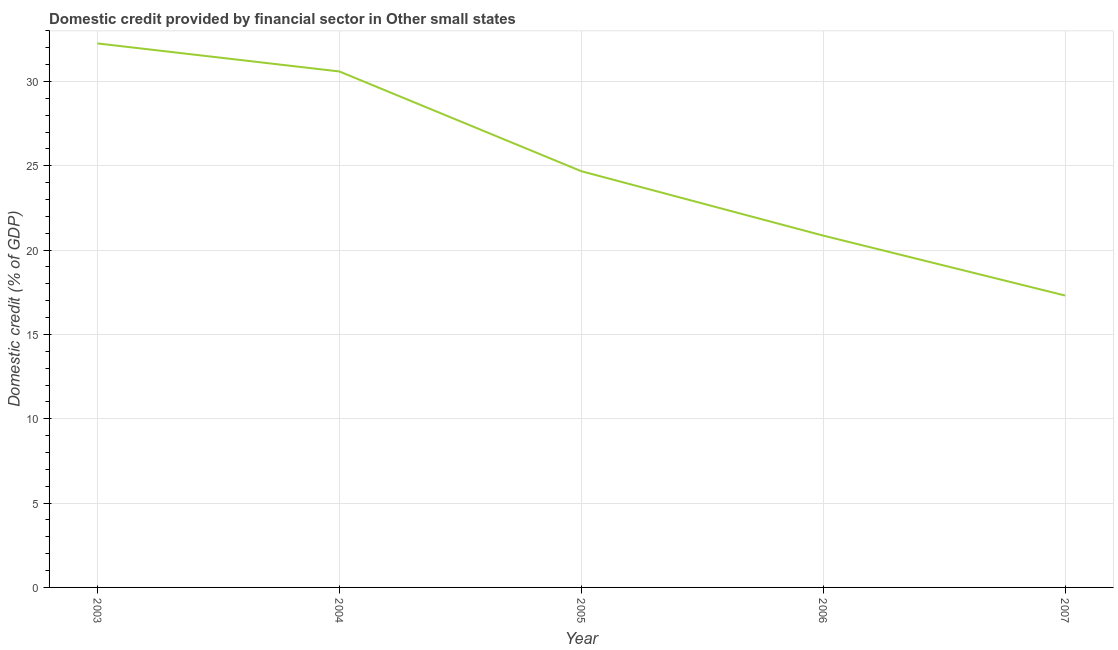What is the domestic credit provided by financial sector in 2003?
Make the answer very short. 32.26. Across all years, what is the maximum domestic credit provided by financial sector?
Provide a short and direct response. 32.26. Across all years, what is the minimum domestic credit provided by financial sector?
Ensure brevity in your answer.  17.31. In which year was the domestic credit provided by financial sector minimum?
Your answer should be very brief. 2007. What is the sum of the domestic credit provided by financial sector?
Your answer should be very brief. 125.7. What is the difference between the domestic credit provided by financial sector in 2005 and 2006?
Keep it short and to the point. 3.82. What is the average domestic credit provided by financial sector per year?
Make the answer very short. 25.14. What is the median domestic credit provided by financial sector?
Keep it short and to the point. 24.68. Do a majority of the years between 2006 and 2003 (inclusive) have domestic credit provided by financial sector greater than 27 %?
Ensure brevity in your answer.  Yes. What is the ratio of the domestic credit provided by financial sector in 2006 to that in 2007?
Your answer should be very brief. 1.21. Is the domestic credit provided by financial sector in 2003 less than that in 2007?
Keep it short and to the point. No. Is the difference between the domestic credit provided by financial sector in 2006 and 2007 greater than the difference between any two years?
Keep it short and to the point. No. What is the difference between the highest and the second highest domestic credit provided by financial sector?
Provide a short and direct response. 1.66. What is the difference between the highest and the lowest domestic credit provided by financial sector?
Give a very brief answer. 14.95. In how many years, is the domestic credit provided by financial sector greater than the average domestic credit provided by financial sector taken over all years?
Your response must be concise. 2. How many lines are there?
Ensure brevity in your answer.  1. What is the difference between two consecutive major ticks on the Y-axis?
Offer a very short reply. 5. Does the graph contain any zero values?
Offer a terse response. No. What is the title of the graph?
Make the answer very short. Domestic credit provided by financial sector in Other small states. What is the label or title of the X-axis?
Ensure brevity in your answer.  Year. What is the label or title of the Y-axis?
Keep it short and to the point. Domestic credit (% of GDP). What is the Domestic credit (% of GDP) of 2003?
Your response must be concise. 32.26. What is the Domestic credit (% of GDP) of 2004?
Your response must be concise. 30.59. What is the Domestic credit (% of GDP) of 2005?
Provide a succinct answer. 24.68. What is the Domestic credit (% of GDP) in 2006?
Offer a very short reply. 20.86. What is the Domestic credit (% of GDP) in 2007?
Offer a terse response. 17.31. What is the difference between the Domestic credit (% of GDP) in 2003 and 2004?
Give a very brief answer. 1.66. What is the difference between the Domestic credit (% of GDP) in 2003 and 2005?
Give a very brief answer. 7.58. What is the difference between the Domestic credit (% of GDP) in 2003 and 2006?
Provide a short and direct response. 11.39. What is the difference between the Domestic credit (% of GDP) in 2003 and 2007?
Ensure brevity in your answer.  14.95. What is the difference between the Domestic credit (% of GDP) in 2004 and 2005?
Your response must be concise. 5.91. What is the difference between the Domestic credit (% of GDP) in 2004 and 2006?
Your answer should be compact. 9.73. What is the difference between the Domestic credit (% of GDP) in 2004 and 2007?
Provide a short and direct response. 13.28. What is the difference between the Domestic credit (% of GDP) in 2005 and 2006?
Your response must be concise. 3.82. What is the difference between the Domestic credit (% of GDP) in 2005 and 2007?
Ensure brevity in your answer.  7.37. What is the difference between the Domestic credit (% of GDP) in 2006 and 2007?
Offer a very short reply. 3.55. What is the ratio of the Domestic credit (% of GDP) in 2003 to that in 2004?
Make the answer very short. 1.05. What is the ratio of the Domestic credit (% of GDP) in 2003 to that in 2005?
Give a very brief answer. 1.31. What is the ratio of the Domestic credit (% of GDP) in 2003 to that in 2006?
Offer a very short reply. 1.55. What is the ratio of the Domestic credit (% of GDP) in 2003 to that in 2007?
Provide a short and direct response. 1.86. What is the ratio of the Domestic credit (% of GDP) in 2004 to that in 2005?
Provide a succinct answer. 1.24. What is the ratio of the Domestic credit (% of GDP) in 2004 to that in 2006?
Keep it short and to the point. 1.47. What is the ratio of the Domestic credit (% of GDP) in 2004 to that in 2007?
Your response must be concise. 1.77. What is the ratio of the Domestic credit (% of GDP) in 2005 to that in 2006?
Make the answer very short. 1.18. What is the ratio of the Domestic credit (% of GDP) in 2005 to that in 2007?
Your answer should be very brief. 1.43. What is the ratio of the Domestic credit (% of GDP) in 2006 to that in 2007?
Keep it short and to the point. 1.21. 